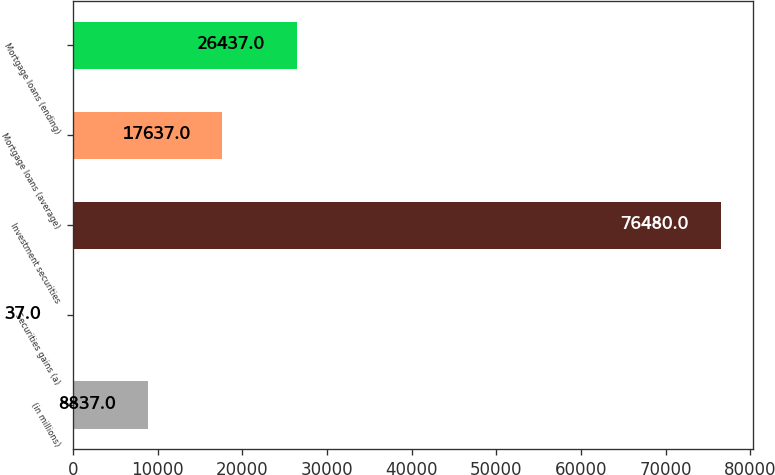Convert chart to OTSL. <chart><loc_0><loc_0><loc_500><loc_500><bar_chart><fcel>(in millions)<fcel>Securities gains (a)<fcel>Investment securities<fcel>Mortgage loans (average)<fcel>Mortgage loans (ending)<nl><fcel>8837<fcel>37<fcel>76480<fcel>17637<fcel>26437<nl></chart> 